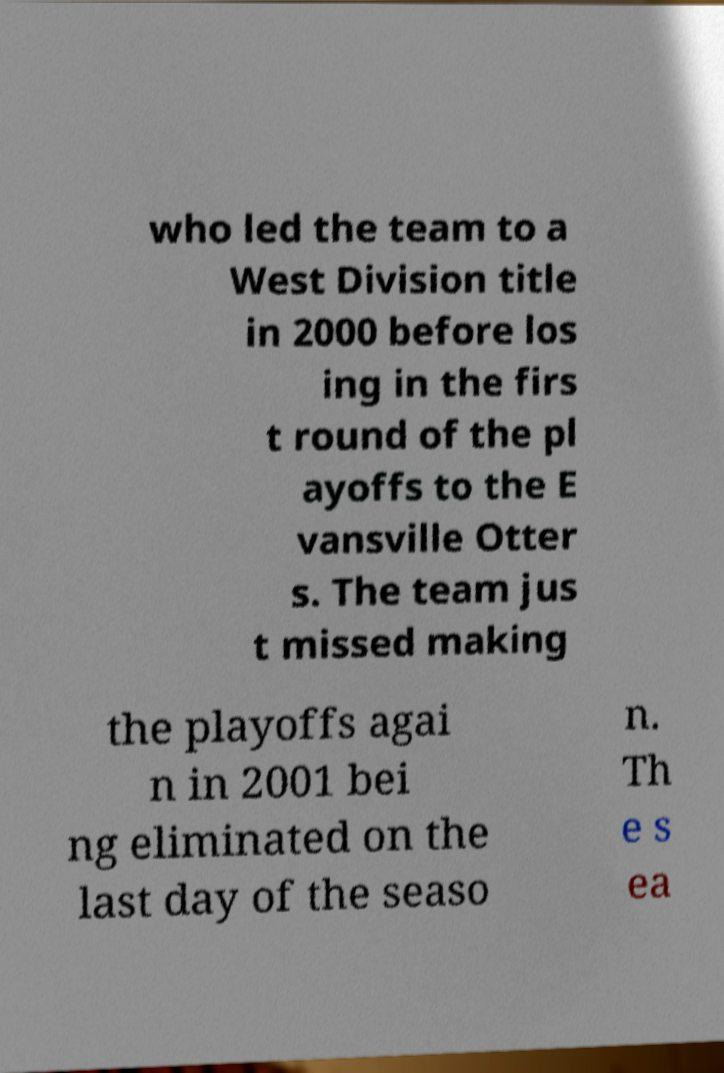Could you extract and type out the text from this image? who led the team to a West Division title in 2000 before los ing in the firs t round of the pl ayoffs to the E vansville Otter s. The team jus t missed making the playoffs agai n in 2001 bei ng eliminated on the last day of the seaso n. Th e s ea 